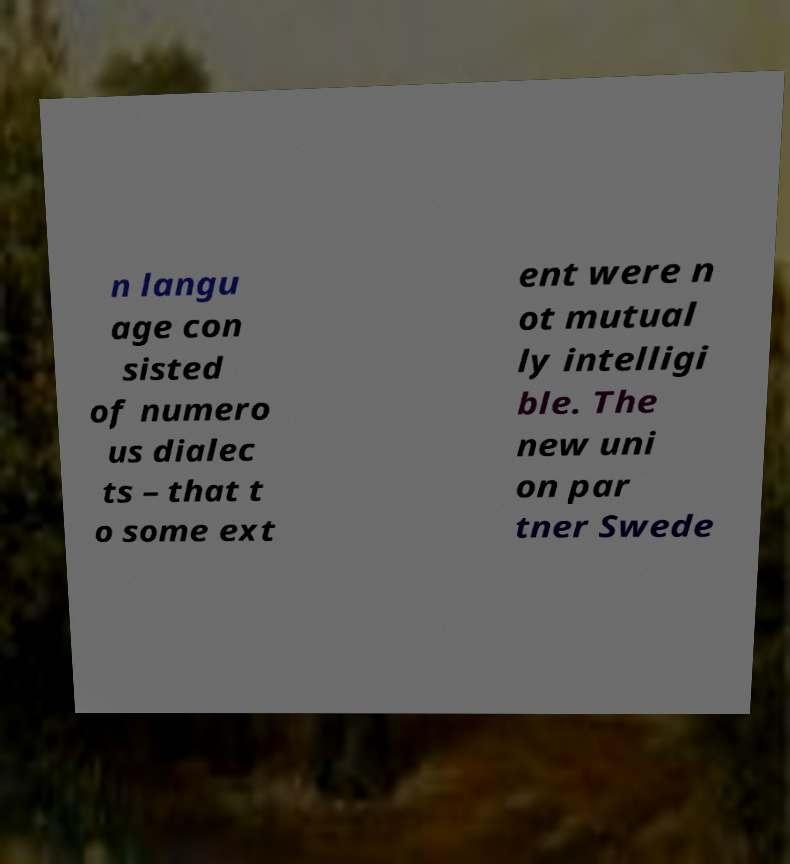Could you extract and type out the text from this image? n langu age con sisted of numero us dialec ts – that t o some ext ent were n ot mutual ly intelligi ble. The new uni on par tner Swede 